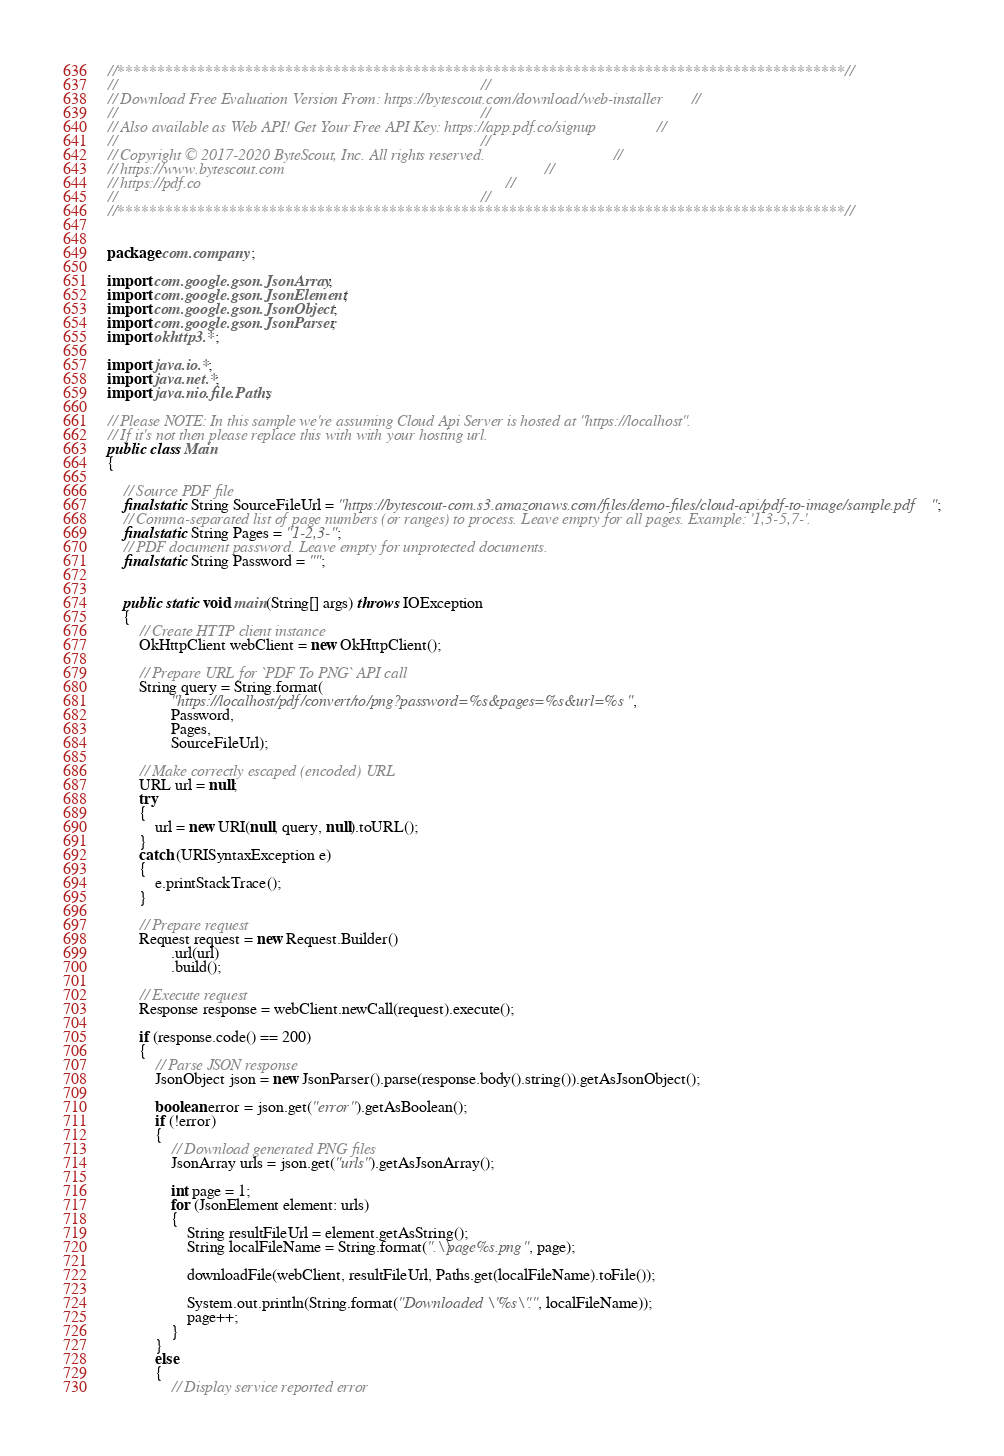<code> <loc_0><loc_0><loc_500><loc_500><_Java_>//*******************************************************************************************//
//                                                                                           //
// Download Free Evaluation Version From: https://bytescout.com/download/web-installer       //
//                                                                                           //
// Also available as Web API! Get Your Free API Key: https://app.pdf.co/signup               //
//                                                                                           //
// Copyright © 2017-2020 ByteScout, Inc. All rights reserved.                                //
// https://www.bytescout.com                                                                 //
// https://pdf.co                                                                            //
//                                                                                           //
//*******************************************************************************************//


package com.company;

import com.google.gson.JsonArray;
import com.google.gson.JsonElement;
import com.google.gson.JsonObject;
import com.google.gson.JsonParser;
import okhttp3.*;

import java.io.*;
import java.net.*;
import java.nio.file.Paths;

// Please NOTE: In this sample we're assuming Cloud Api Server is hosted at "https://localhost". 
// If it's not then please replace this with with your hosting url.
public class Main
{
 
    // Source PDF file
	final static String SourceFileUrl = "https://bytescout-com.s3.amazonaws.com/files/demo-files/cloud-api/pdf-to-image/sample.pdf";
    // Comma-separated list of page numbers (or ranges) to process. Leave empty for all pages. Example: '1,3-5,7-'.
    final static String Pages = "1-2,3-";
    // PDF document password. Leave empty for unprotected documents.
    final static String Password = "";


    public static void main(String[] args) throws IOException
    {
        // Create HTTP client instance
        OkHttpClient webClient = new OkHttpClient();

        // Prepare URL for `PDF To PNG` API call
        String query = String.format(
                "https://localhost/pdf/convert/to/png?password=%s&pages=%s&url=%s",
                Password,
                Pages,
                SourceFileUrl);

        // Make correctly escaped (encoded) URL
        URL url = null;
        try
        {
            url = new URI(null, query, null).toURL();
        }
        catch (URISyntaxException e)
        {
            e.printStackTrace();
        }

        // Prepare request
        Request request = new Request.Builder()
                .url(url)
                .build();

        // Execute request
        Response response = webClient.newCall(request).execute();

        if (response.code() == 200)
        {
            // Parse JSON response
            JsonObject json = new JsonParser().parse(response.body().string()).getAsJsonObject();

            boolean error = json.get("error").getAsBoolean();
            if (!error)
            {
                // Download generated PNG files
                JsonArray urls = json.get("urls").getAsJsonArray();

                int page = 1;
                for (JsonElement element: urls)
                {
                    String resultFileUrl = element.getAsString();
                    String localFileName = String.format(".\\page%s.png", page);

                    downloadFile(webClient, resultFileUrl, Paths.get(localFileName).toFile());

                    System.out.println(String.format("Downloaded \"%s\".", localFileName));
                    page++;
                }
            }
            else
            {
                // Display service reported error</code> 